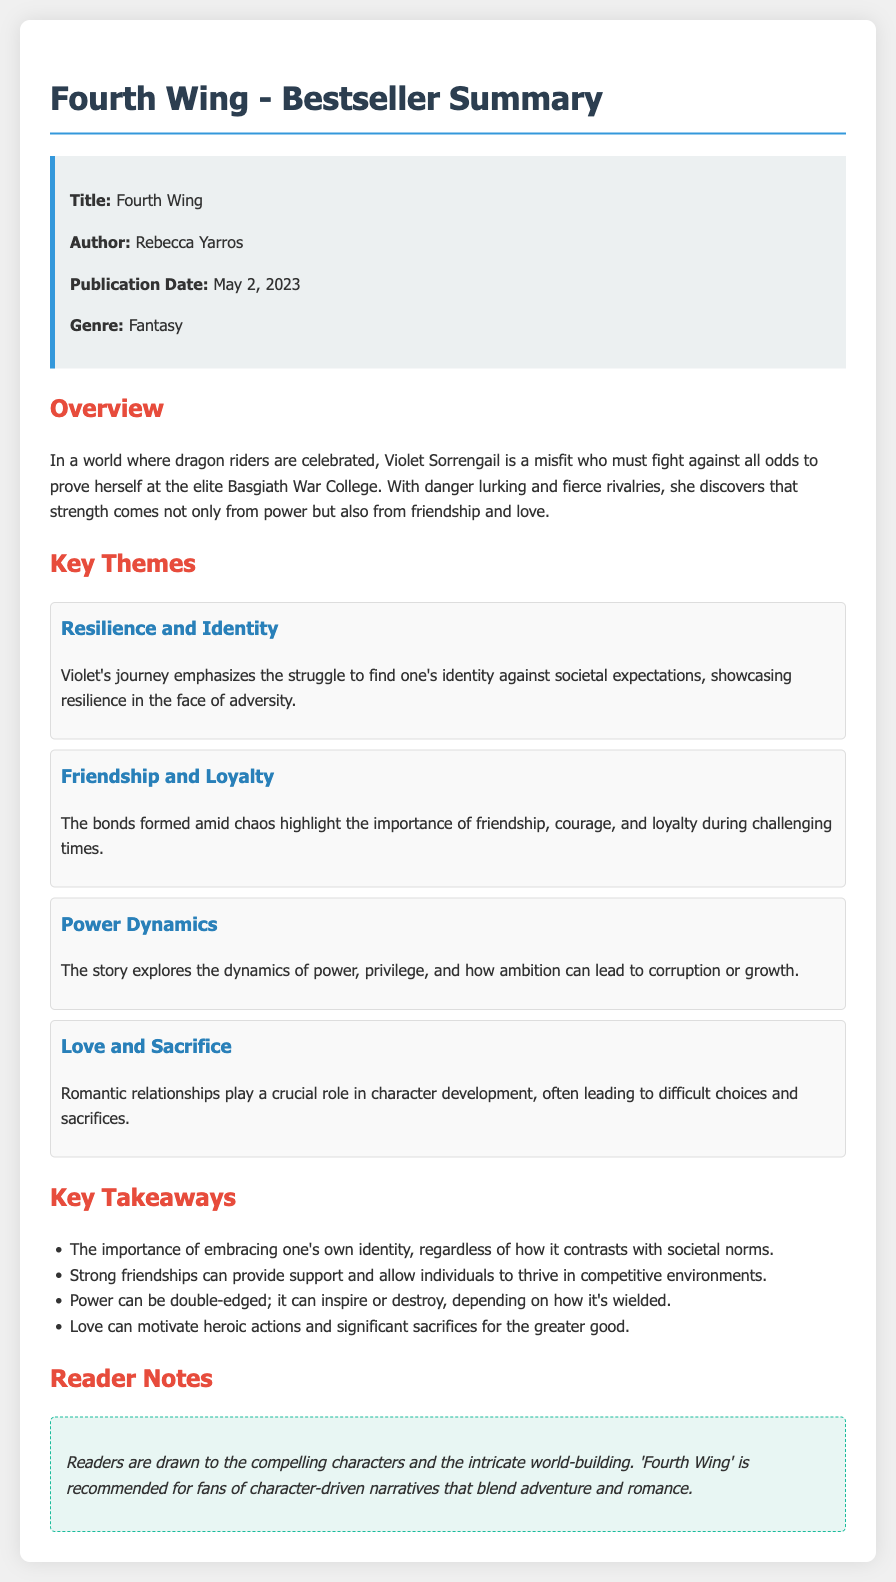What is the title of the book? The title of the book is presented prominently at the beginning of the document.
Answer: Fourth Wing Who is the author of "Fourth Wing"? The author's name is included in the book information section.
Answer: Rebecca Yarros When was "Fourth Wing" published? The publication date is stated clearly in the book information section.
Answer: May 2, 2023 What genre does "Fourth Wing" belong to? The genre of the book is listed in the book information section.
Answer: Fantasy What is a key theme related to friendship in the book? The document discusses the theme of friendship in the designated themes section.
Answer: Friendship and Loyalty How does Violet Sorrengail's journey primarily reflect resilience? The document explains through key themes how Violet's struggle showcases resilience.
Answer: Resilience and Identity What is one of the key takeaways regarding power dynamics? The takeaways section summarizes insights about power from the narrative.
Answer: Power can be double-edged; it can inspire or destroy What type of readers is "Fourth Wing" recommended for? The reader notes section specifies the audience the book appeals to.
Answer: Fans of character-driven narratives What is highlighted in the overview for Violet's character? The overview section details Violet's challenges and strengths.
Answer: Misfit who must fight against all odds 